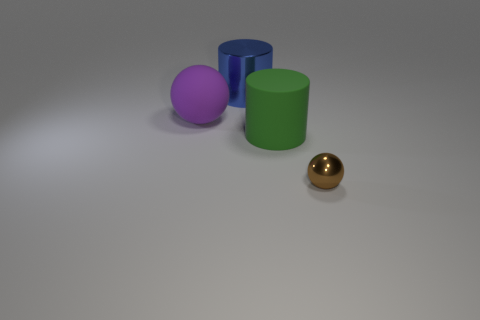How many red things are big shiny cylinders or large cylinders?
Make the answer very short. 0. Are there an equal number of large purple balls that are to the right of the brown ball and metal cylinders in front of the big blue metallic thing?
Make the answer very short. Yes. There is a ball on the left side of the metal object that is in front of the shiny object that is on the left side of the large green thing; what color is it?
Make the answer very short. Purple. Are there any other things of the same color as the metal ball?
Provide a succinct answer. No. There is a ball that is to the left of the small brown metallic ball; how big is it?
Give a very brief answer. Large. There is a purple object that is the same size as the green matte cylinder; what shape is it?
Provide a short and direct response. Sphere. Does the sphere to the left of the small brown metallic thing have the same material as the object that is right of the big green rubber cylinder?
Offer a terse response. No. What material is the big thing on the right side of the metallic cylinder that is to the left of the large green object?
Provide a succinct answer. Rubber. What size is the rubber object to the left of the cylinder that is in front of the shiny object behind the small object?
Your response must be concise. Large. Is the size of the green matte object the same as the purple matte object?
Offer a very short reply. Yes. 